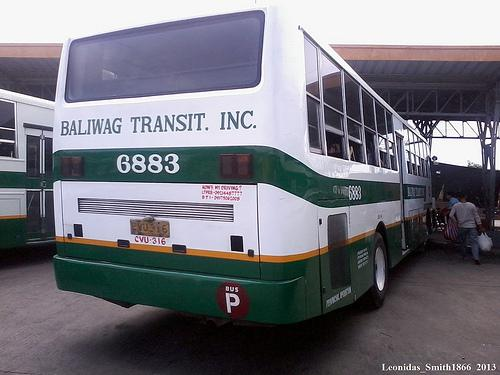Question: what two colors are the bus?
Choices:
A. Green, white.
B. Red, yellow.
C. Green, blue.
D. Purple, orange.
Answer with the letter. Answer: A Question: where was this photo taken?
Choices:
A. Bus station.
B. Train station.
C. Airport.
D. College.
Answer with the letter. Answer: A Question: who is sitting on top of the bus?
Choices:
A. No one.
B. Tourists.
C. Family.
D. Sisters.
Answer with the letter. Answer: A Question: how many men are seen to the right of the bus?
Choices:
A. Three.
B. Four.
C. Two.
D. Five.
Answer with the letter. Answer: C Question: what color is the ground?
Choices:
A. Black.
B. Brown.
C. Grey.
D. White.
Answer with the letter. Answer: C 